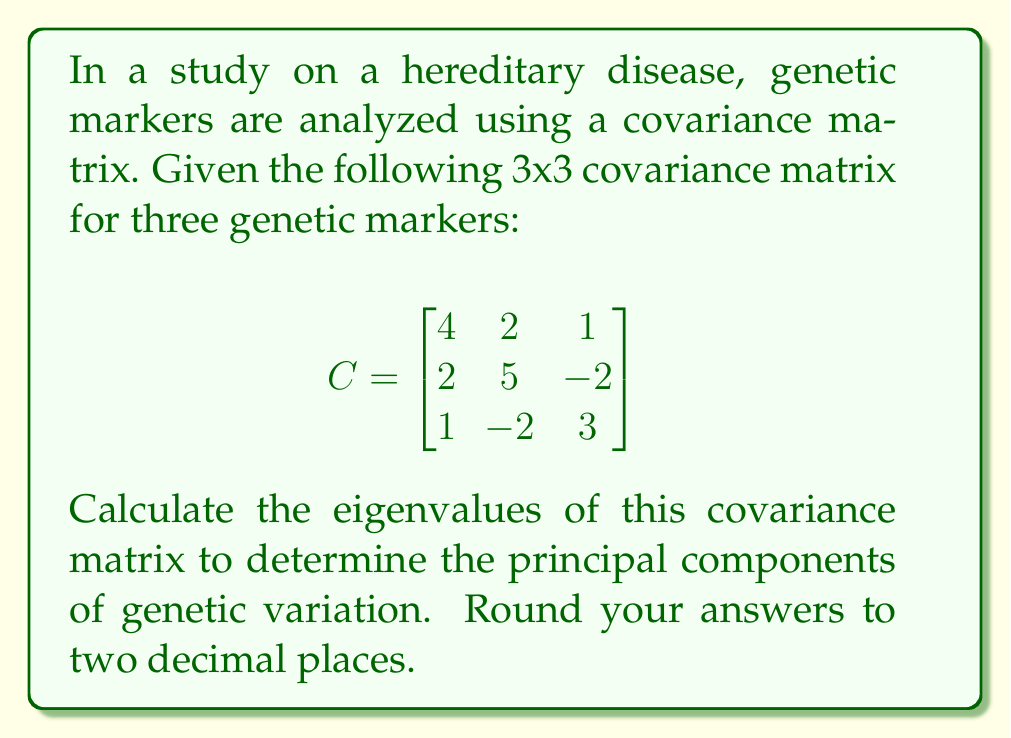Help me with this question. To find the eigenvalues of the covariance matrix C, we need to solve the characteristic equation:

$$ \det(C - \lambda I) = 0 $$

Where $\lambda$ represents the eigenvalues and I is the 3x3 identity matrix.

Step 1: Set up the characteristic equation:
$$ \det\begin{pmatrix}
4-\lambda & 2 & 1 \\
2 & 5-\lambda & -2 \\
1 & -2 & 3-\lambda
\end{pmatrix} = 0 $$

Step 2: Expand the determinant:
$$ (4-\lambda)[(5-\lambda)(3-\lambda)+4] - 2[2(3-\lambda)-1] + 1[2(-2)-(5-\lambda)] = 0 $$

Step 3: Simplify:
$$ (4-\lambda)(15-8\lambda+\lambda^2+4) - 2(6-2\lambda-1) + 1(-4-5+\lambda) = 0 $$
$$ (4-\lambda)(19-8\lambda+\lambda^2) - 2(5-2\lambda) + (-9+\lambda) = 0 $$
$$ 76-32\lambda+4\lambda^2-19\lambda+8\lambda^2-\lambda^3 - 10+4\lambda - 9+\lambda = 0 $$

Step 4: Collect terms:
$$ -\lambda^3 + 12\lambda^2 - 46\lambda + 57 = 0 $$

Step 5: Solve the cubic equation. This can be done using various methods such as the cubic formula or numerical methods. Using a calculator or computer algebra system, we find the roots:

$\lambda_1 \approx 7.47$
$\lambda_2 \approx 3.55$
$\lambda_3 \approx 0.98$

These eigenvalues represent the variances along the principal components of genetic variation.
Answer: $\lambda_1 \approx 7.47$, $\lambda_2 \approx 3.55$, $\lambda_3 \approx 0.98$ 